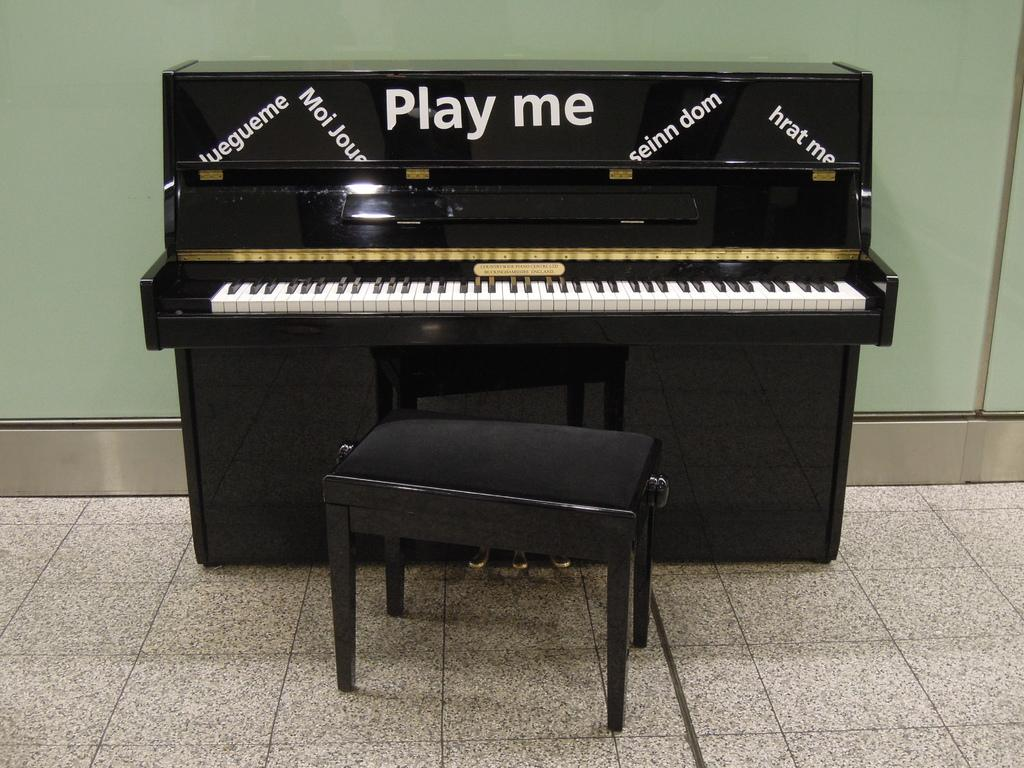What musical instrument is present in the image? There is a piano in the image. Is there any furniture associated with the piano in the image? Yes, there is a stool in the image. Where are the piano and stool located in the image? Both the piano and the stool are on the floor. How far away is the bike from the shelf in the image? There is no bike or shelf present in the image. 